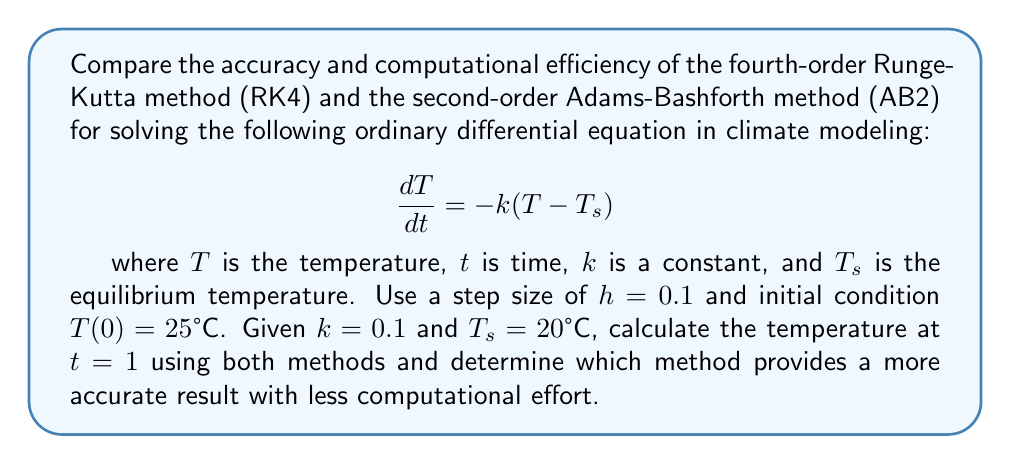Can you solve this math problem? To compare the RK4 and AB2 methods, we'll solve the ODE using both methods and analyze their accuracy and computational efficiency.

1. Analytical solution:
The exact solution to this ODE is:
$$T(t) = T_s + (T_0 - T_s)e^{-kt}$$
At $t = 1$, the exact temperature is:
$$T(1) = 20 + (25 - 20)e^{-0.1 \cdot 1} = 24.5123°C$$

2. Fourth-order Runge-Kutta method (RK4):
For the given ODE, $f(t, T) = -k(T - T_s)$

The RK4 method is given by:
$$T_{n+1} = T_n + \frac{1}{6}(k_1 + 2k_2 + 2k_3 + k_4)$$
where:
$$\begin{align}
k_1 &= hf(t_n, T_n) \\
k_2 &= hf(t_n + \frac{h}{2}, T_n + \frac{k_1}{2}) \\
k_3 &= hf(t_n + \frac{h}{2}, T_n + \frac{k_2}{2}) \\
k_4 &= hf(t_n + h, T_n + k_3)
\end{align}$$

Using $h = 0.1$ and starting from $T_0 = 25°C$, we need 10 steps to reach $t = 1$. After performing these calculations, we get:

$$T_{RK4}(1) \approx 24.5124°C$$

3. Second-order Adams-Bashforth method (AB2):
The AB2 method requires two initial points. We can use the Euler method to calculate the second point:

$$T_1 = T_0 + hf(t_0, T_0) = 25 + 0.1 \cdot (-0.1(25 - 20)) = 24.95°C$$

The AB2 method is given by:
$$T_{n+1} = T_n + \frac{h}{2}(3f(t_n, T_n) - f(t_{n-1}, T_{n-1}))$$

Using this formula for the remaining 8 steps, we get:

$$T_{AB2}(1) \approx 24.5167°C$$

4. Comparison:
- Accuracy: The absolute errors are:
  RK4: |24.5124 - 24.5123| = 0.0001°C
  AB2: |24.5167 - 24.5123| = 0.0044°C
  RK4 is more accurate than AB2.

- Computational efficiency:
  RK4 requires 4 function evaluations per step.
  AB2 requires 1 function evaluation per step (after the initial step).
  AB2 is more computationally efficient.

5. Conclusion:
The RK4 method provides a more accurate result but requires more computational effort. The AB2 method is less accurate but more computationally efficient. For this specific problem, the RK4 method would be preferred due to its significantly higher accuracy, unless computational resources are severely limited.
Answer: RK4 is more accurate (error: 0.0001°C) but less efficient. AB2 is less accurate (error: 0.0044°C) but more efficient. RK4 is preferred for higher accuracy. 